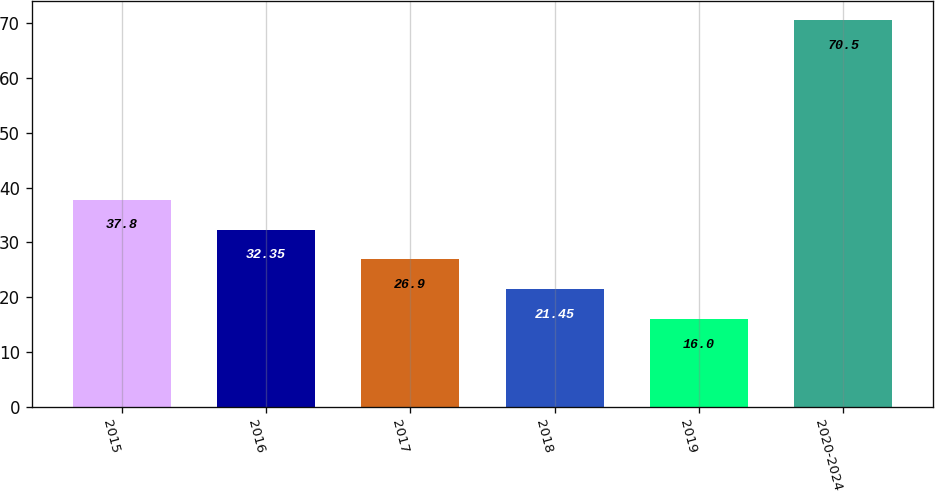Convert chart. <chart><loc_0><loc_0><loc_500><loc_500><bar_chart><fcel>2015<fcel>2016<fcel>2017<fcel>2018<fcel>2019<fcel>2020-2024<nl><fcel>37.8<fcel>32.35<fcel>26.9<fcel>21.45<fcel>16<fcel>70.5<nl></chart> 